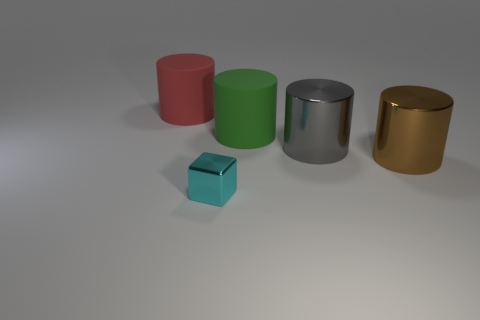Subtract 1 cylinders. How many cylinders are left? 3 Add 5 green cylinders. How many objects exist? 10 Subtract all blocks. How many objects are left? 4 Subtract all purple shiny cubes. Subtract all green matte cylinders. How many objects are left? 4 Add 3 green things. How many green things are left? 4 Add 1 cylinders. How many cylinders exist? 5 Subtract 0 cyan cylinders. How many objects are left? 5 